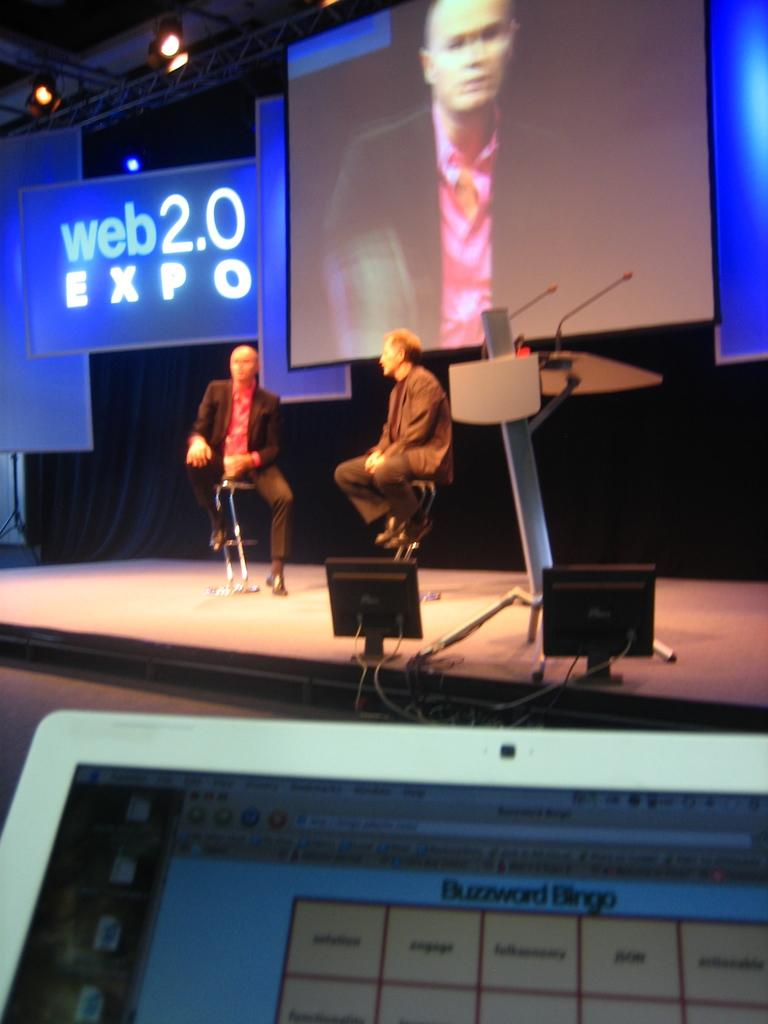Provide a one-sentence caption for the provided image. Two men sit on stools before a large screen and a banner with the words web2.0 Expo on it. 